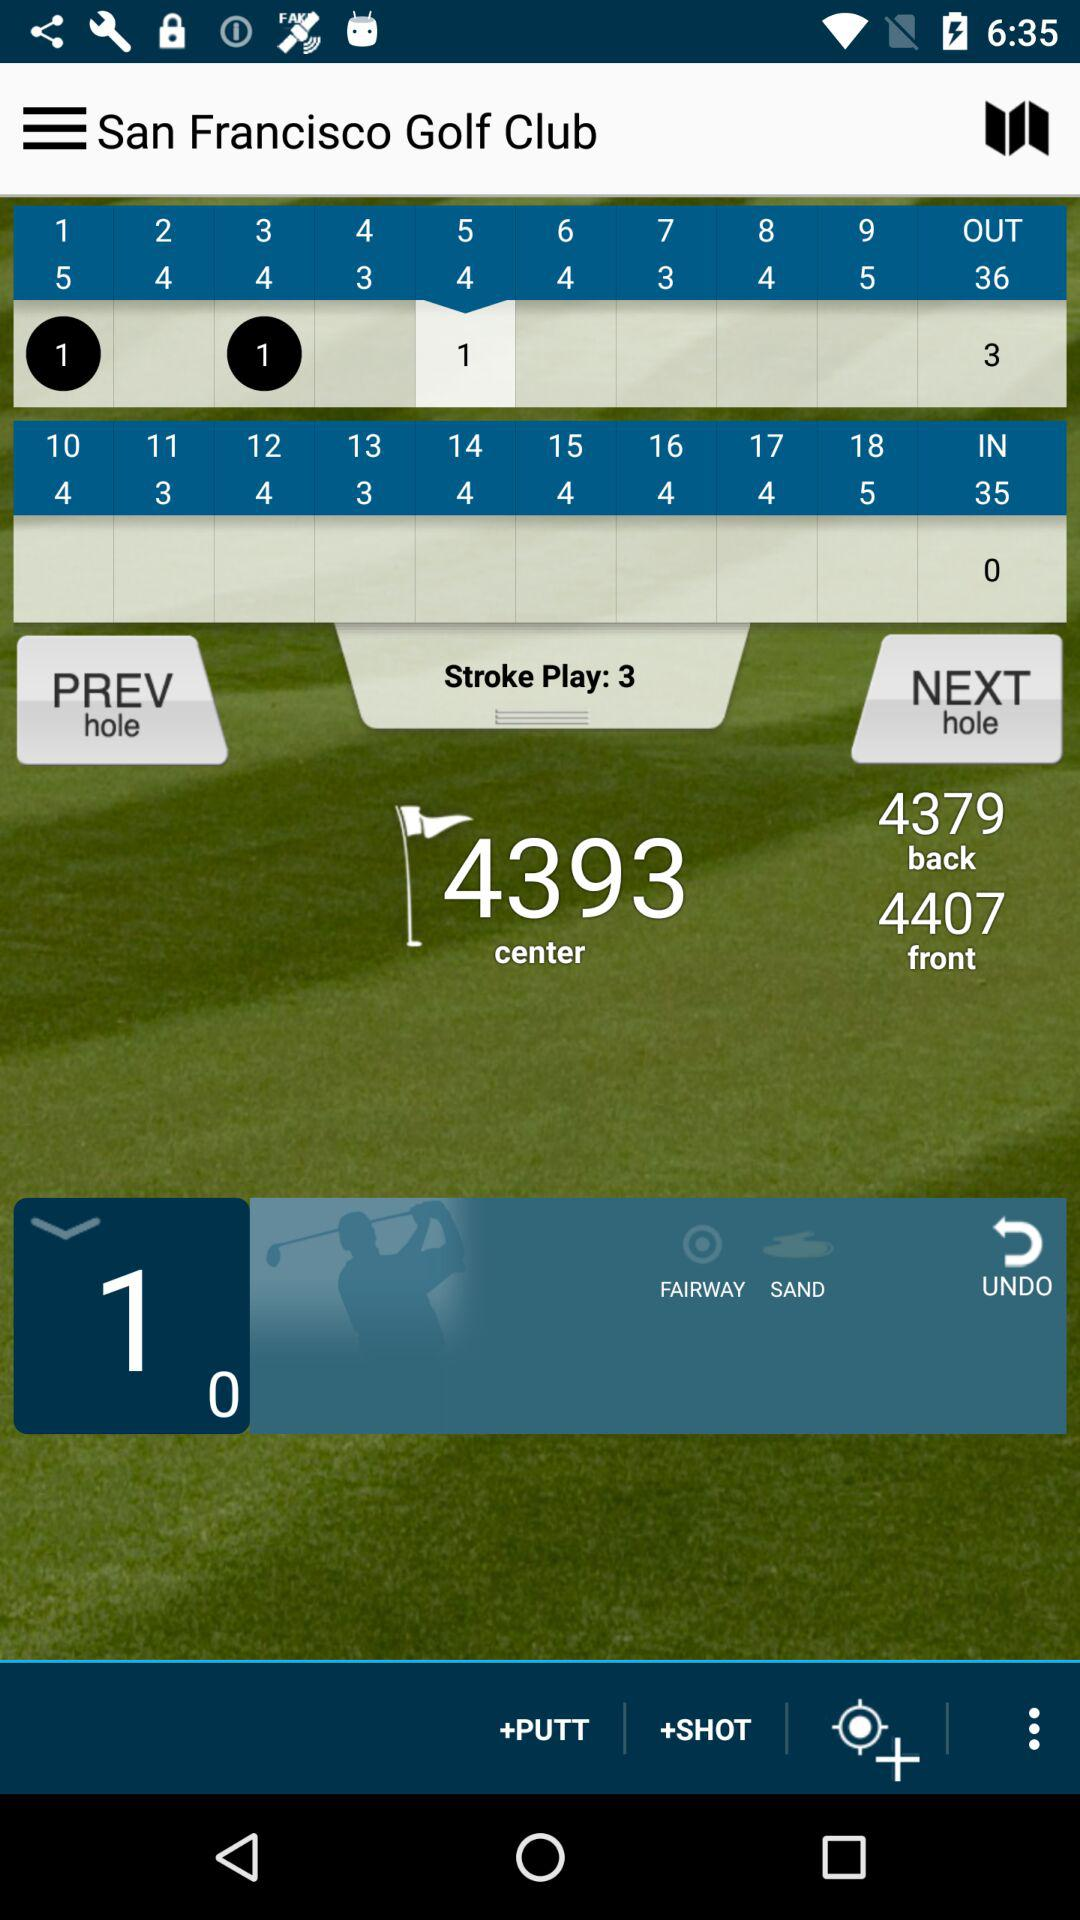What is the center score? The center score is 4393. 